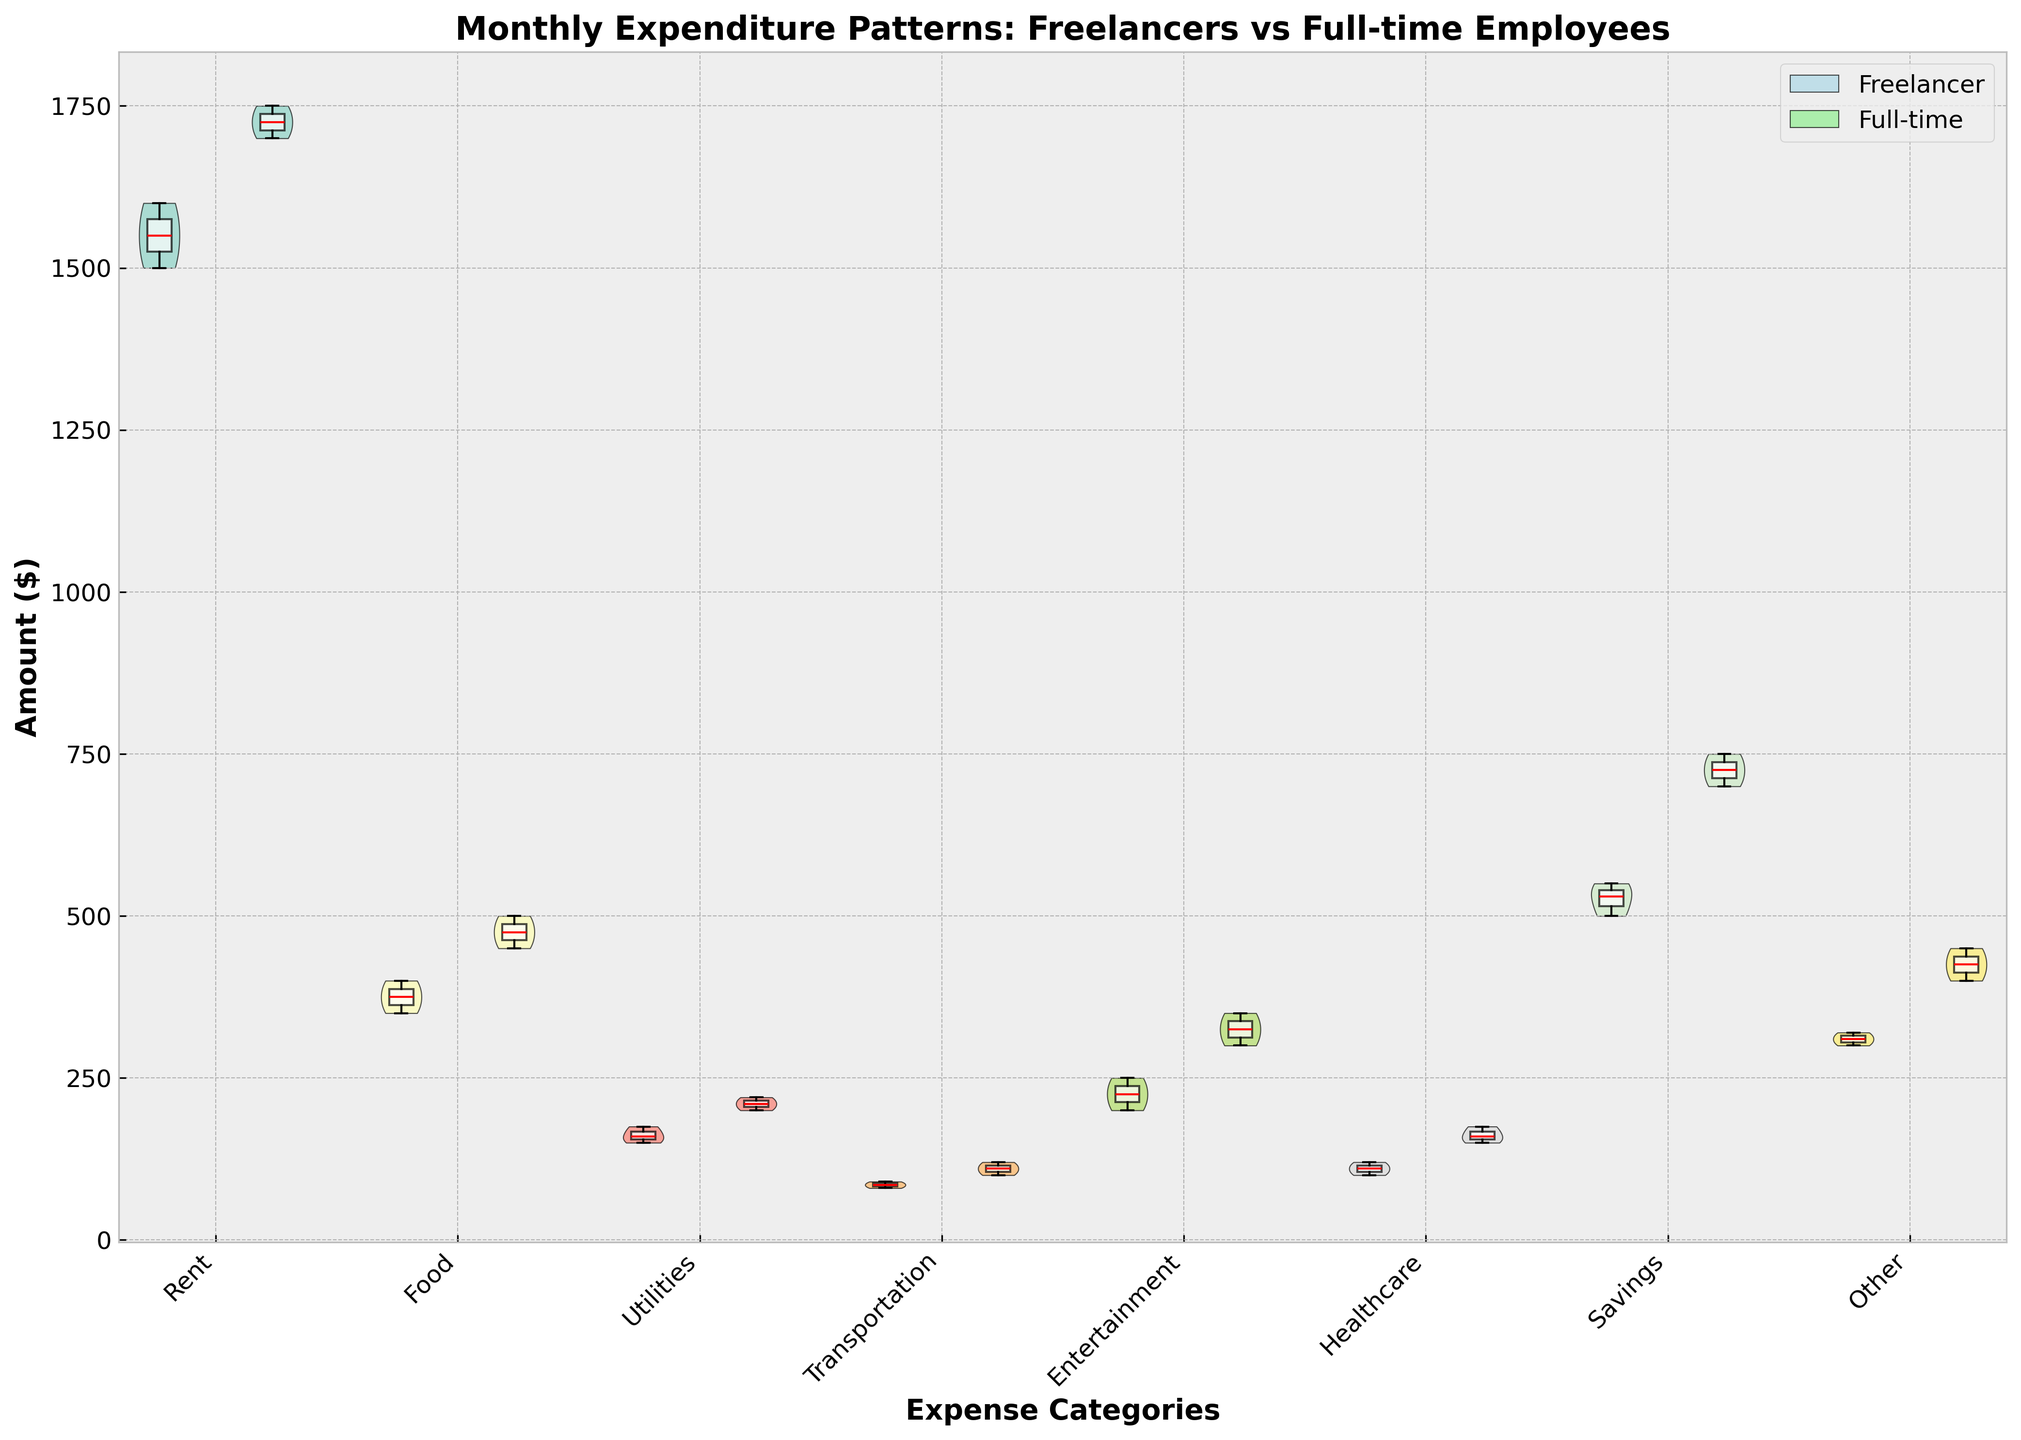what is the title of the chart? The title is usually located at the top of the chart and describes what the chart is about. For this visual, the title is "Monthly Expenditure Patterns: Freelancers vs Full-time Employees".
Answer: Monthly Expenditure Patterns: Freelancers vs Full-time Employees which expense category shows the highest median amount for full-time employees? The median can be identified by the red horizontal line in the box plot. For full-time employees, the highest such line appears in the 'Rent' category.
Answer: Rent which group spends more on transportation on average? First, compare the position of the median lines (the red horizontal lines) for the 'Transportation' category in both groups. The full-time employees' median line is higher than that of freelancers.
Answer: Full-time employees how do the ranges of healthcare expenditures compare between freelancers and full-time employees? To compare ranges, look at the width of the violin plots and the span of the box plots. Full-time employees have a wider range from the minimum to maximum compared to freelancers, whose range is narrower.
Answer: Full-time employees have a wider range what does the legend indicate in this chart? The legend in the upper right corner provides color references for the different groups, identifying "Freelancer" with light blue and "Full-time" with light green.
Answer: Freelancer: light blue, Full-time: light green which group shows more variability in entertainment expenditure? Variability can be observed by the width and spread of the violin plots. Full-time employees show more variability in 'Entertainment' expenditure as the violin plot for them is both wider and spans a greater range.
Answer: Full-time employees how does rent expenditure compare between freelancers and full-time employees? To compare rent expenditure, check both the violin plots and the box plots for this category. Full-time employees tend to have higher expenditure on rent as shown by both higher median and overall range.
Answer: Full-time employees spend more in which category do freelancers have a higher maximum expenditure compared to full-time employees? Maximum expenditure can be identified by the upper extremes of the box plots. For the 'Healthcare' category, freelancers have a slightly higher maximum value.
Answer: Healthcare which expense category shows a similar expenditure pattern for both freelancers and full-time employees? The 'Transportation' category shows similar patterns in expenditure for both groups, indicated both by the closeness of the median lines and the overlapping shapes of the violin plots.
Answer: Transportation do freelancers or full-time employees save more on average? By examining the median lines in the 'Savings' category, it is clear that full-time employees have a higher median savings compared to freelancers.
Answer: Full-time employees 